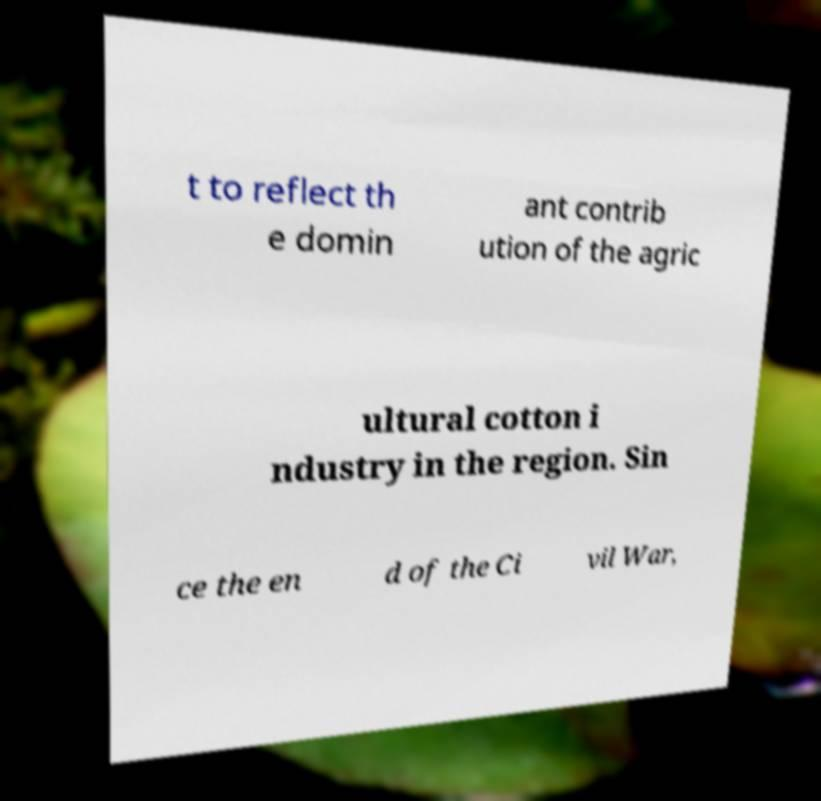I need the written content from this picture converted into text. Can you do that? t to reflect th e domin ant contrib ution of the agric ultural cotton i ndustry in the region. Sin ce the en d of the Ci vil War, 